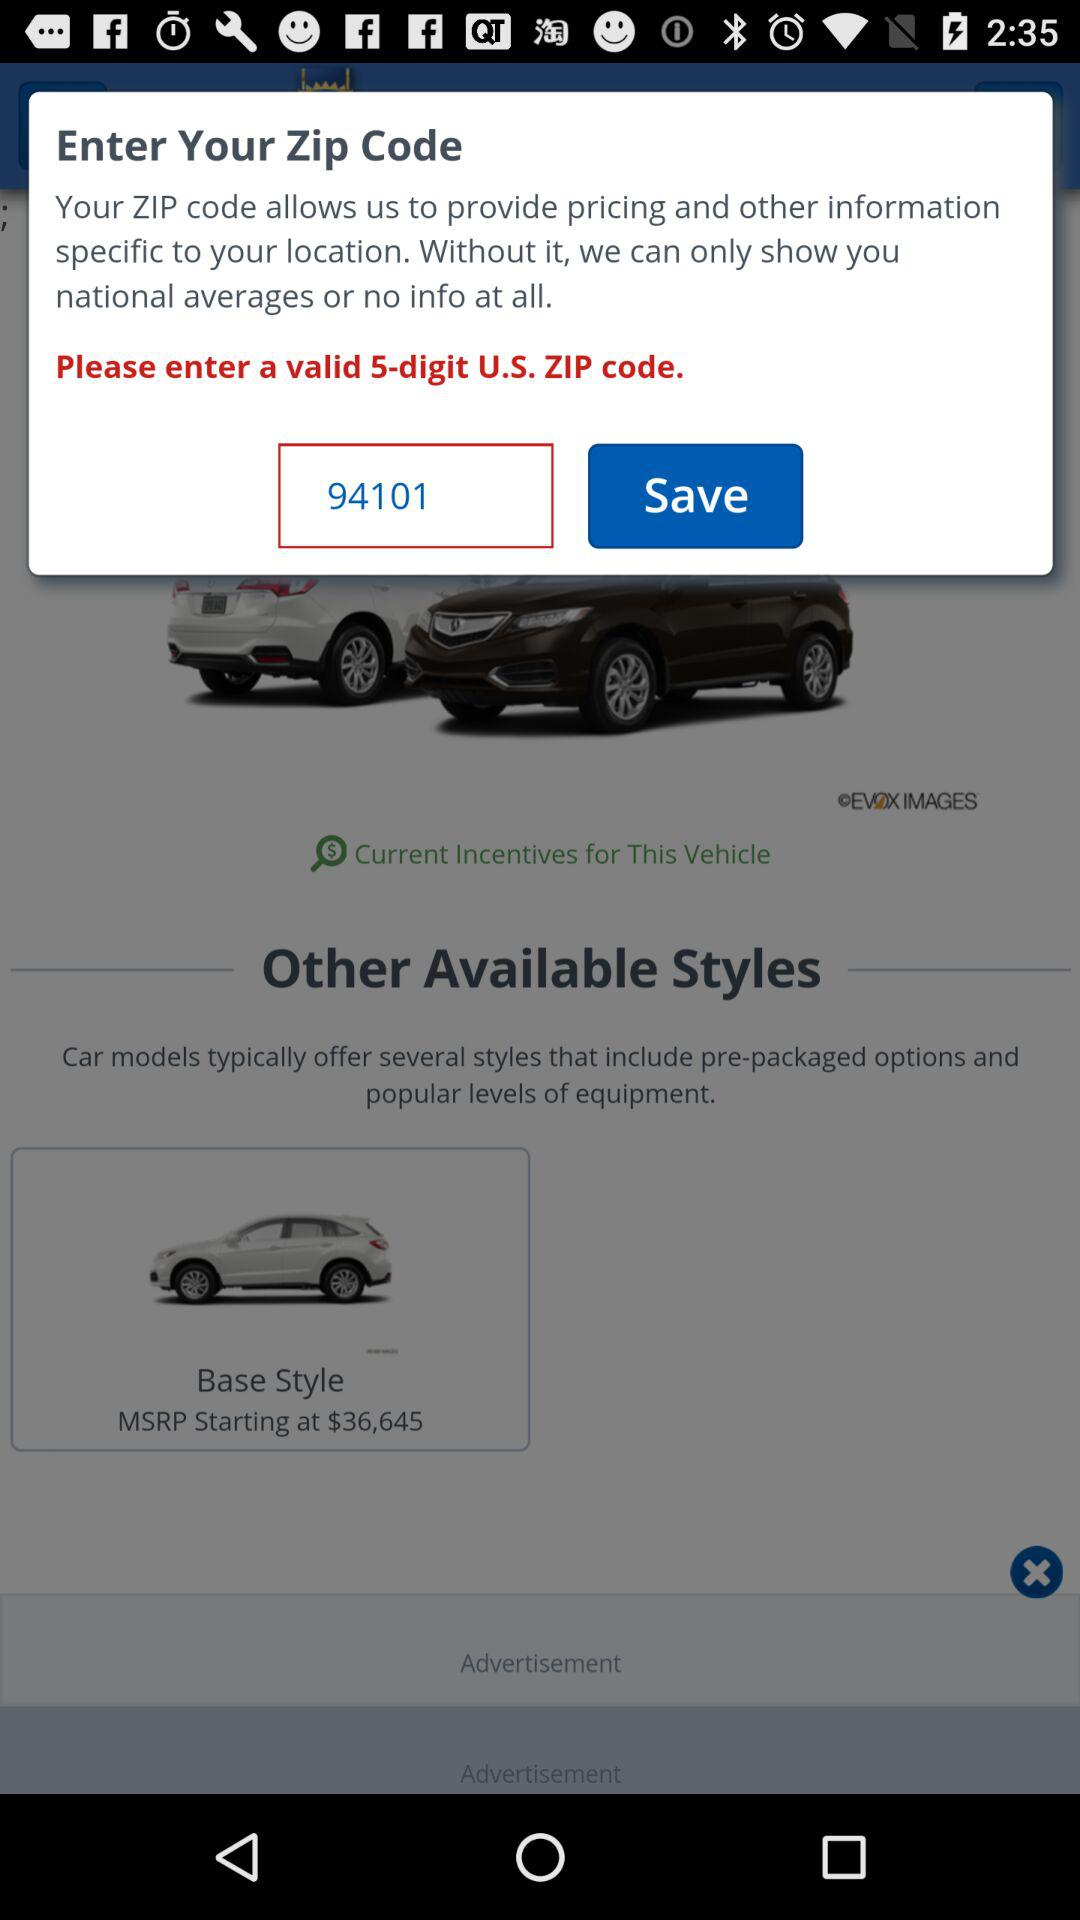How many digits does the ZIP code have? The ZIP code has 5 digits. 